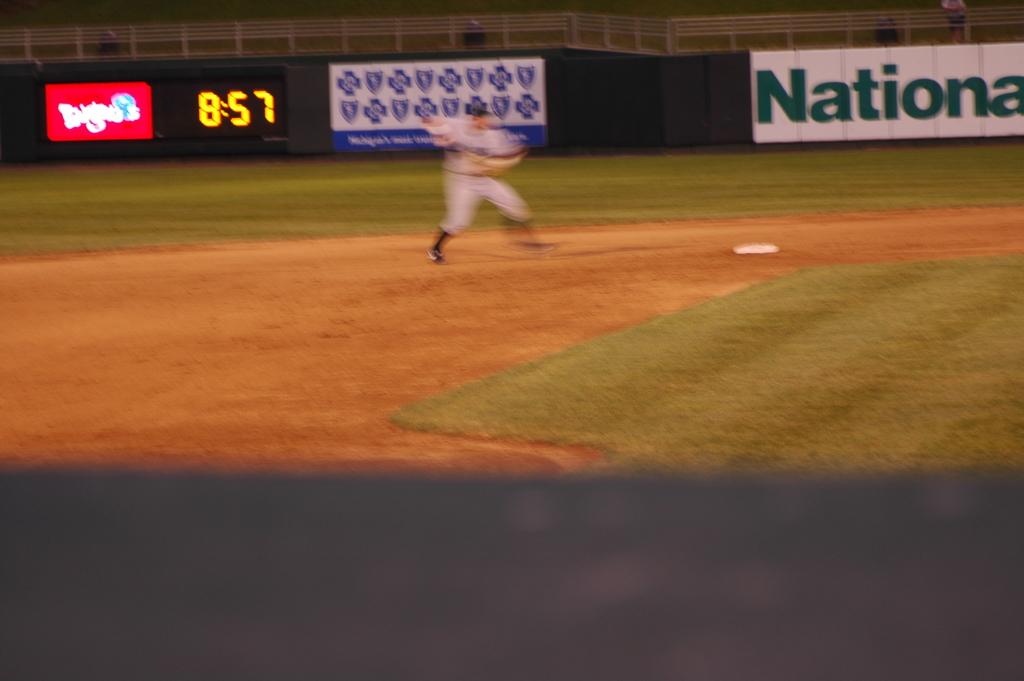What does the word in green say?
Provide a succinct answer. National. 